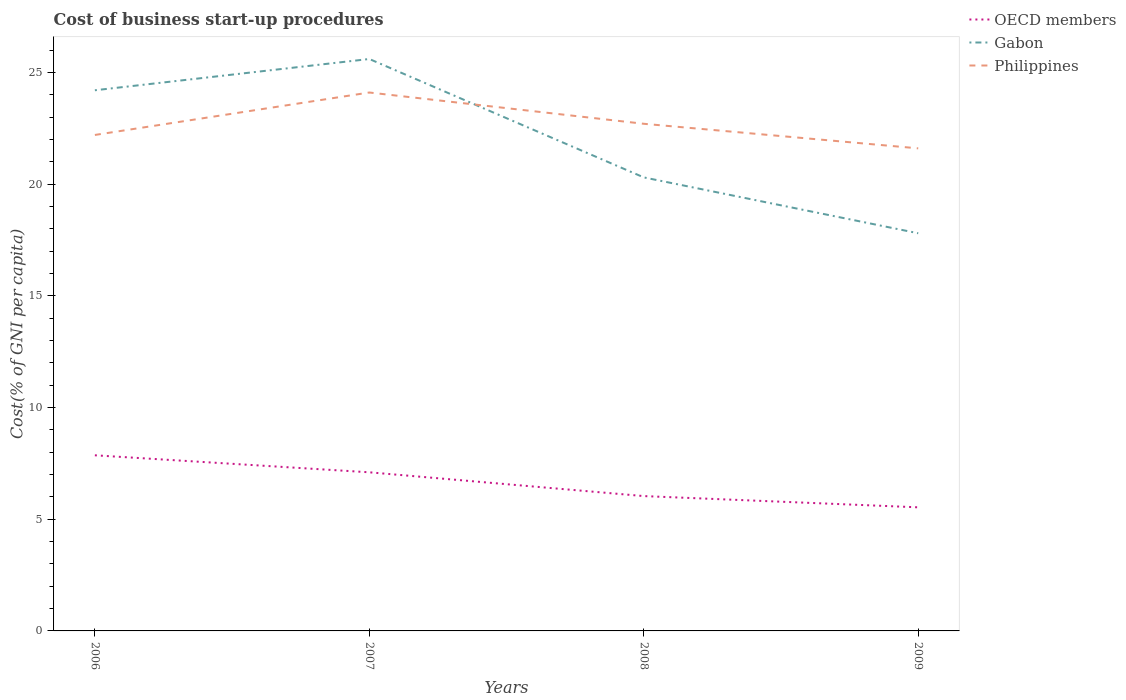How many different coloured lines are there?
Your response must be concise. 3. Does the line corresponding to Gabon intersect with the line corresponding to OECD members?
Offer a very short reply. No. Across all years, what is the maximum cost of business start-up procedures in OECD members?
Provide a succinct answer. 5.53. In which year was the cost of business start-up procedures in OECD members maximum?
Provide a succinct answer. 2009. What is the total cost of business start-up procedures in Philippines in the graph?
Provide a short and direct response. 1.1. How many years are there in the graph?
Make the answer very short. 4. What is the difference between two consecutive major ticks on the Y-axis?
Keep it short and to the point. 5. Are the values on the major ticks of Y-axis written in scientific E-notation?
Make the answer very short. No. Does the graph contain any zero values?
Offer a terse response. No. Does the graph contain grids?
Keep it short and to the point. No. What is the title of the graph?
Give a very brief answer. Cost of business start-up procedures. What is the label or title of the X-axis?
Provide a short and direct response. Years. What is the label or title of the Y-axis?
Make the answer very short. Cost(% of GNI per capita). What is the Cost(% of GNI per capita) in OECD members in 2006?
Ensure brevity in your answer.  7.86. What is the Cost(% of GNI per capita) of Gabon in 2006?
Your answer should be very brief. 24.2. What is the Cost(% of GNI per capita) in Philippines in 2006?
Your answer should be compact. 22.2. What is the Cost(% of GNI per capita) of OECD members in 2007?
Your response must be concise. 7.1. What is the Cost(% of GNI per capita) in Gabon in 2007?
Your response must be concise. 25.6. What is the Cost(% of GNI per capita) of Philippines in 2007?
Make the answer very short. 24.1. What is the Cost(% of GNI per capita) in OECD members in 2008?
Provide a succinct answer. 6.04. What is the Cost(% of GNI per capita) of Gabon in 2008?
Offer a terse response. 20.3. What is the Cost(% of GNI per capita) in Philippines in 2008?
Provide a succinct answer. 22.7. What is the Cost(% of GNI per capita) in OECD members in 2009?
Provide a succinct answer. 5.53. What is the Cost(% of GNI per capita) in Gabon in 2009?
Offer a very short reply. 17.8. What is the Cost(% of GNI per capita) of Philippines in 2009?
Keep it short and to the point. 21.6. Across all years, what is the maximum Cost(% of GNI per capita) in OECD members?
Give a very brief answer. 7.86. Across all years, what is the maximum Cost(% of GNI per capita) of Gabon?
Your answer should be compact. 25.6. Across all years, what is the maximum Cost(% of GNI per capita) of Philippines?
Your answer should be very brief. 24.1. Across all years, what is the minimum Cost(% of GNI per capita) of OECD members?
Your response must be concise. 5.53. Across all years, what is the minimum Cost(% of GNI per capita) of Gabon?
Give a very brief answer. 17.8. Across all years, what is the minimum Cost(% of GNI per capita) of Philippines?
Your answer should be very brief. 21.6. What is the total Cost(% of GNI per capita) of OECD members in the graph?
Give a very brief answer. 26.53. What is the total Cost(% of GNI per capita) in Gabon in the graph?
Your response must be concise. 87.9. What is the total Cost(% of GNI per capita) of Philippines in the graph?
Offer a terse response. 90.6. What is the difference between the Cost(% of GNI per capita) of OECD members in 2006 and that in 2007?
Provide a short and direct response. 0.76. What is the difference between the Cost(% of GNI per capita) of Gabon in 2006 and that in 2007?
Give a very brief answer. -1.4. What is the difference between the Cost(% of GNI per capita) in Philippines in 2006 and that in 2007?
Provide a short and direct response. -1.9. What is the difference between the Cost(% of GNI per capita) in OECD members in 2006 and that in 2008?
Offer a very short reply. 1.83. What is the difference between the Cost(% of GNI per capita) in Gabon in 2006 and that in 2008?
Provide a succinct answer. 3.9. What is the difference between the Cost(% of GNI per capita) in Philippines in 2006 and that in 2008?
Make the answer very short. -0.5. What is the difference between the Cost(% of GNI per capita) in OECD members in 2006 and that in 2009?
Provide a short and direct response. 2.33. What is the difference between the Cost(% of GNI per capita) of OECD members in 2007 and that in 2008?
Your response must be concise. 1.06. What is the difference between the Cost(% of GNI per capita) in Gabon in 2007 and that in 2008?
Your response must be concise. 5.3. What is the difference between the Cost(% of GNI per capita) in OECD members in 2007 and that in 2009?
Your answer should be compact. 1.57. What is the difference between the Cost(% of GNI per capita) in Philippines in 2007 and that in 2009?
Your answer should be very brief. 2.5. What is the difference between the Cost(% of GNI per capita) of OECD members in 2008 and that in 2009?
Your response must be concise. 0.5. What is the difference between the Cost(% of GNI per capita) of Philippines in 2008 and that in 2009?
Offer a very short reply. 1.1. What is the difference between the Cost(% of GNI per capita) of OECD members in 2006 and the Cost(% of GNI per capita) of Gabon in 2007?
Give a very brief answer. -17.74. What is the difference between the Cost(% of GNI per capita) of OECD members in 2006 and the Cost(% of GNI per capita) of Philippines in 2007?
Provide a short and direct response. -16.24. What is the difference between the Cost(% of GNI per capita) of OECD members in 2006 and the Cost(% of GNI per capita) of Gabon in 2008?
Your answer should be compact. -12.44. What is the difference between the Cost(% of GNI per capita) in OECD members in 2006 and the Cost(% of GNI per capita) in Philippines in 2008?
Your response must be concise. -14.84. What is the difference between the Cost(% of GNI per capita) in Gabon in 2006 and the Cost(% of GNI per capita) in Philippines in 2008?
Your response must be concise. 1.5. What is the difference between the Cost(% of GNI per capita) in OECD members in 2006 and the Cost(% of GNI per capita) in Gabon in 2009?
Give a very brief answer. -9.94. What is the difference between the Cost(% of GNI per capita) in OECD members in 2006 and the Cost(% of GNI per capita) in Philippines in 2009?
Offer a very short reply. -13.74. What is the difference between the Cost(% of GNI per capita) of OECD members in 2007 and the Cost(% of GNI per capita) of Gabon in 2008?
Make the answer very short. -13.2. What is the difference between the Cost(% of GNI per capita) of OECD members in 2007 and the Cost(% of GNI per capita) of Philippines in 2008?
Offer a very short reply. -15.6. What is the difference between the Cost(% of GNI per capita) in OECD members in 2007 and the Cost(% of GNI per capita) in Gabon in 2009?
Your answer should be very brief. -10.7. What is the difference between the Cost(% of GNI per capita) of OECD members in 2007 and the Cost(% of GNI per capita) of Philippines in 2009?
Your answer should be compact. -14.5. What is the difference between the Cost(% of GNI per capita) of Gabon in 2007 and the Cost(% of GNI per capita) of Philippines in 2009?
Offer a very short reply. 4. What is the difference between the Cost(% of GNI per capita) of OECD members in 2008 and the Cost(% of GNI per capita) of Gabon in 2009?
Offer a very short reply. -11.76. What is the difference between the Cost(% of GNI per capita) of OECD members in 2008 and the Cost(% of GNI per capita) of Philippines in 2009?
Keep it short and to the point. -15.56. What is the difference between the Cost(% of GNI per capita) of Gabon in 2008 and the Cost(% of GNI per capita) of Philippines in 2009?
Provide a short and direct response. -1.3. What is the average Cost(% of GNI per capita) of OECD members per year?
Keep it short and to the point. 6.63. What is the average Cost(% of GNI per capita) of Gabon per year?
Give a very brief answer. 21.98. What is the average Cost(% of GNI per capita) in Philippines per year?
Give a very brief answer. 22.65. In the year 2006, what is the difference between the Cost(% of GNI per capita) of OECD members and Cost(% of GNI per capita) of Gabon?
Offer a very short reply. -16.34. In the year 2006, what is the difference between the Cost(% of GNI per capita) of OECD members and Cost(% of GNI per capita) of Philippines?
Ensure brevity in your answer.  -14.34. In the year 2007, what is the difference between the Cost(% of GNI per capita) in OECD members and Cost(% of GNI per capita) in Gabon?
Your answer should be compact. -18.5. In the year 2007, what is the difference between the Cost(% of GNI per capita) of OECD members and Cost(% of GNI per capita) of Philippines?
Your response must be concise. -17. In the year 2008, what is the difference between the Cost(% of GNI per capita) in OECD members and Cost(% of GNI per capita) in Gabon?
Your answer should be very brief. -14.26. In the year 2008, what is the difference between the Cost(% of GNI per capita) in OECD members and Cost(% of GNI per capita) in Philippines?
Your answer should be very brief. -16.66. In the year 2009, what is the difference between the Cost(% of GNI per capita) in OECD members and Cost(% of GNI per capita) in Gabon?
Provide a succinct answer. -12.27. In the year 2009, what is the difference between the Cost(% of GNI per capita) of OECD members and Cost(% of GNI per capita) of Philippines?
Your answer should be compact. -16.07. What is the ratio of the Cost(% of GNI per capita) of OECD members in 2006 to that in 2007?
Provide a succinct answer. 1.11. What is the ratio of the Cost(% of GNI per capita) of Gabon in 2006 to that in 2007?
Your answer should be compact. 0.95. What is the ratio of the Cost(% of GNI per capita) in Philippines in 2006 to that in 2007?
Ensure brevity in your answer.  0.92. What is the ratio of the Cost(% of GNI per capita) of OECD members in 2006 to that in 2008?
Keep it short and to the point. 1.3. What is the ratio of the Cost(% of GNI per capita) in Gabon in 2006 to that in 2008?
Provide a succinct answer. 1.19. What is the ratio of the Cost(% of GNI per capita) in OECD members in 2006 to that in 2009?
Ensure brevity in your answer.  1.42. What is the ratio of the Cost(% of GNI per capita) of Gabon in 2006 to that in 2009?
Provide a succinct answer. 1.36. What is the ratio of the Cost(% of GNI per capita) in Philippines in 2006 to that in 2009?
Your answer should be compact. 1.03. What is the ratio of the Cost(% of GNI per capita) of OECD members in 2007 to that in 2008?
Provide a succinct answer. 1.18. What is the ratio of the Cost(% of GNI per capita) of Gabon in 2007 to that in 2008?
Offer a very short reply. 1.26. What is the ratio of the Cost(% of GNI per capita) in Philippines in 2007 to that in 2008?
Provide a short and direct response. 1.06. What is the ratio of the Cost(% of GNI per capita) in OECD members in 2007 to that in 2009?
Provide a short and direct response. 1.28. What is the ratio of the Cost(% of GNI per capita) of Gabon in 2007 to that in 2009?
Provide a short and direct response. 1.44. What is the ratio of the Cost(% of GNI per capita) in Philippines in 2007 to that in 2009?
Your response must be concise. 1.12. What is the ratio of the Cost(% of GNI per capita) of OECD members in 2008 to that in 2009?
Give a very brief answer. 1.09. What is the ratio of the Cost(% of GNI per capita) in Gabon in 2008 to that in 2009?
Your answer should be compact. 1.14. What is the ratio of the Cost(% of GNI per capita) of Philippines in 2008 to that in 2009?
Give a very brief answer. 1.05. What is the difference between the highest and the second highest Cost(% of GNI per capita) in OECD members?
Make the answer very short. 0.76. What is the difference between the highest and the second highest Cost(% of GNI per capita) in Philippines?
Make the answer very short. 1.4. What is the difference between the highest and the lowest Cost(% of GNI per capita) in OECD members?
Your answer should be compact. 2.33. 